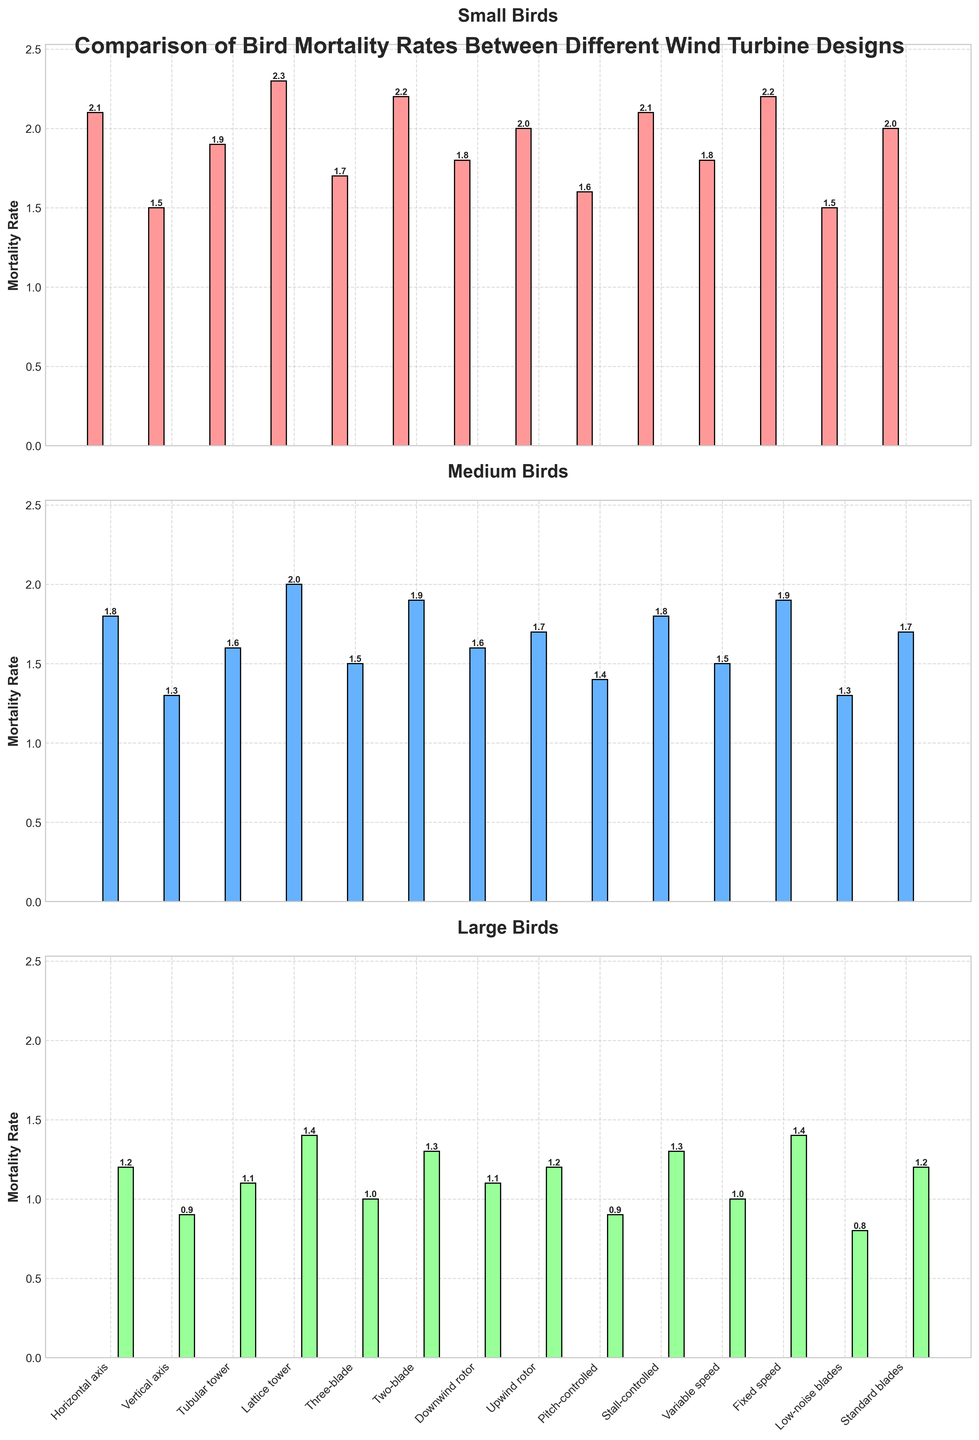What is the mortality rate of small birds for the Horizontal axis design and the Low-noise blades design? For small birds, the mortality rate for the Horizontal axis design is represented by the height of the corresponding bar in the first subplot. Similarly, the mortality rate for the Low-noise blades design is indicated by the respective bar height. The values are 2.1 and 1.5 respectively.
Answer: 2.1 and 1.5 Which turbine design has the highest mortality rate for large birds? In the subplot for large birds, the tallest bar represents the wind turbine design with the highest mortality rate. The Lattice tower design has the tallest bar, indicating it has the highest mortality rate for large birds.
Answer: Lattice tower What is the average mortality rate for medium birds across all turbine designs? To find the average, sum up the mortality rates for medium birds across all designs and then divide by the number of designs. The sum is (1.8 + 1.3 + 1.6 + 2.0 + 1.5 + 1.9 + 1.6 + 1.7 + 1.4 + 1.8 + 1.5 + 1.9 + 1.3 + 1.7) = 23.0, and the number of designs is 14. So, the average is 23.0 / 14 = 1.64.
Answer: 1.64 How does the mortality rate of small birds compare between Two-blade and Pitch-controlled designs? In the first subplot for small birds, the heights of the bars for the Two-blade and Pitch-controlled designs indicate the mortality rates. Two-blade has a mortality rate of 2.2, and Pitch-controlled has a mortality rate of 1.6. The rate for the Two-blade design is higher by 0.6.
Answer: Two-blade has 0.6 higher rate Which turbine design has the lowest mortality rate for medium birds? In the medium birds subplot, the shortest bar represents the design with the lowest mortality rate. The Low-noise blades design has the shortest bar, indicating it has the lowest mortality rate for medium birds.
Answer: Low-noise blades For the Fixed speed design, is the mortality rate higher for medium or large birds? In the subplots for the Fixed speed design, compare the heights of the bars for medium and large birds. The heights are 1.9 for medium birds and 1.4 for large birds, so the mortality rate is higher for medium birds.
Answer: Medium birds What is the combined mortality rate for all bird sizes for Upwind rotor design? Add the mortality rates of small, medium, and large birds for the Upwind rotor design. The rates are 2.0 (small), 1.7 (medium), and 1.2 (large). The combined rate is 2.0 + 1.7 + 1.2 = 4.9.
Answer: 4.9 How does the mortality rate for Stall-controlled design compare between small and large birds? In the subplots, compare the heights of the bars for the Stall-controlled design between small and large birds. The rates are 2.1 for small birds and 1.3 for large birds. The rate for small birds is higher by 0.8.
Answer: Small birds have 0.8 higher rate Which turbine designs have a mortality rate of 1.5 for small birds? In the subplot for small birds, look for bars with a height of 1.5. The designs that match this rate are Vertical axis and Low-noise blades.
Answer: Vertical axis, Low-noise blades 